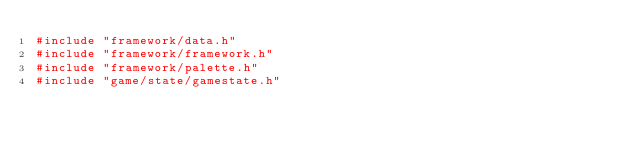<code> <loc_0><loc_0><loc_500><loc_500><_C++_>#include "framework/data.h"
#include "framework/framework.h"
#include "framework/palette.h"
#include "game/state/gamestate.h"</code> 